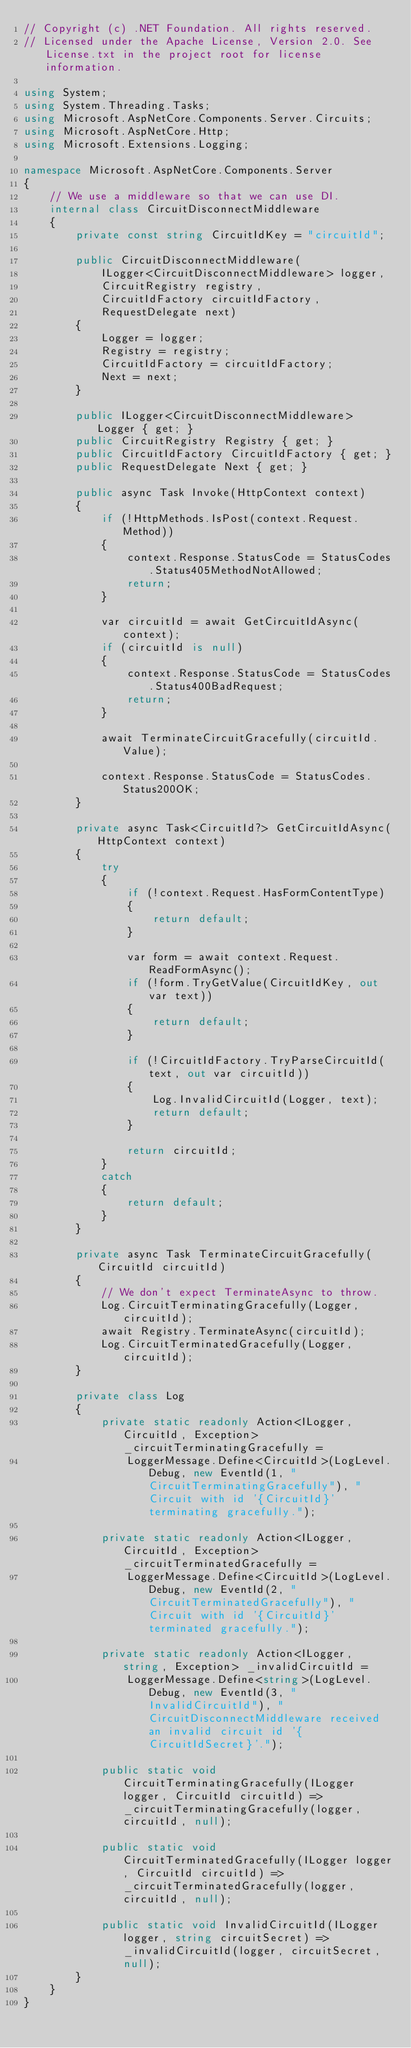Convert code to text. <code><loc_0><loc_0><loc_500><loc_500><_C#_>// Copyright (c) .NET Foundation. All rights reserved.
// Licensed under the Apache License, Version 2.0. See License.txt in the project root for license information.

using System;
using System.Threading.Tasks;
using Microsoft.AspNetCore.Components.Server.Circuits;
using Microsoft.AspNetCore.Http;
using Microsoft.Extensions.Logging;

namespace Microsoft.AspNetCore.Components.Server
{
    // We use a middleware so that we can use DI.
    internal class CircuitDisconnectMiddleware
    {
        private const string CircuitIdKey = "circuitId";

        public CircuitDisconnectMiddleware(
            ILogger<CircuitDisconnectMiddleware> logger,
            CircuitRegistry registry,
            CircuitIdFactory circuitIdFactory,
            RequestDelegate next)
        {
            Logger = logger;
            Registry = registry;
            CircuitIdFactory = circuitIdFactory;
            Next = next;
        }

        public ILogger<CircuitDisconnectMiddleware> Logger { get; }
        public CircuitRegistry Registry { get; }
        public CircuitIdFactory CircuitIdFactory { get; }
        public RequestDelegate Next { get; }

        public async Task Invoke(HttpContext context)
        {
            if (!HttpMethods.IsPost(context.Request.Method))
            {
                context.Response.StatusCode = StatusCodes.Status405MethodNotAllowed;
                return;
            }

            var circuitId = await GetCircuitIdAsync(context);
            if (circuitId is null)
            {
                context.Response.StatusCode = StatusCodes.Status400BadRequest;
                return;
            }

            await TerminateCircuitGracefully(circuitId.Value);

            context.Response.StatusCode = StatusCodes.Status200OK;
        }

        private async Task<CircuitId?> GetCircuitIdAsync(HttpContext context)
        {
            try
            {
                if (!context.Request.HasFormContentType)
                {
                    return default;
                }

                var form = await context.Request.ReadFormAsync();
                if (!form.TryGetValue(CircuitIdKey, out var text))
                {
                    return default;
                }

                if (!CircuitIdFactory.TryParseCircuitId(text, out var circuitId))
                {
                    Log.InvalidCircuitId(Logger, text);
                    return default;
                }

                return circuitId;
            }
            catch
            {
                return default;
            }
        }

        private async Task TerminateCircuitGracefully(CircuitId circuitId)
        {
            // We don't expect TerminateAsync to throw.
            Log.CircuitTerminatingGracefully(Logger, circuitId);
            await Registry.TerminateAsync(circuitId);
            Log.CircuitTerminatedGracefully(Logger, circuitId);
        }

        private class Log
        {
            private static readonly Action<ILogger, CircuitId, Exception> _circuitTerminatingGracefully =
                LoggerMessage.Define<CircuitId>(LogLevel.Debug, new EventId(1, "CircuitTerminatingGracefully"), "Circuit with id '{CircuitId}' terminating gracefully.");

            private static readonly Action<ILogger, CircuitId, Exception> _circuitTerminatedGracefully =
                LoggerMessage.Define<CircuitId>(LogLevel.Debug, new EventId(2, "CircuitTerminatedGracefully"), "Circuit with id '{CircuitId}' terminated gracefully.");

            private static readonly Action<ILogger, string, Exception> _invalidCircuitId =
                LoggerMessage.Define<string>(LogLevel.Debug, new EventId(3, "InvalidCircuitId"), "CircuitDisconnectMiddleware received an invalid circuit id '{CircuitIdSecret}'.");

            public static void CircuitTerminatingGracefully(ILogger logger, CircuitId circuitId) => _circuitTerminatingGracefully(logger, circuitId, null);

            public static void CircuitTerminatedGracefully(ILogger logger, CircuitId circuitId) => _circuitTerminatedGracefully(logger, circuitId, null);

            public static void InvalidCircuitId(ILogger logger, string circuitSecret) => _invalidCircuitId(logger, circuitSecret, null);
        }
    }
}
</code> 